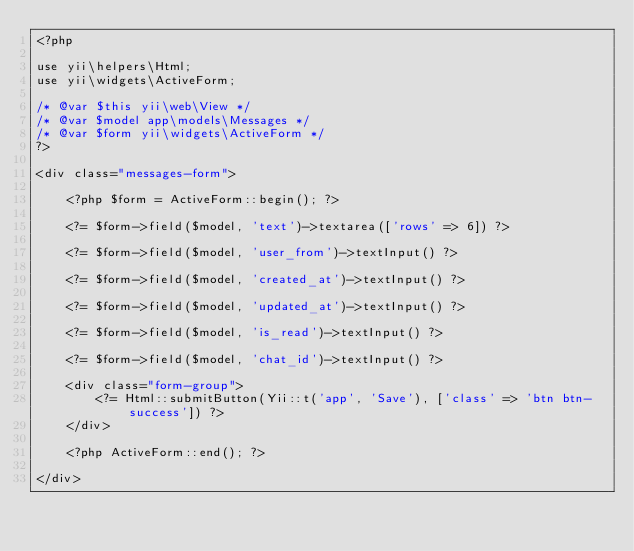<code> <loc_0><loc_0><loc_500><loc_500><_PHP_><?php

use yii\helpers\Html;
use yii\widgets\ActiveForm;

/* @var $this yii\web\View */
/* @var $model app\models\Messages */
/* @var $form yii\widgets\ActiveForm */
?>

<div class="messages-form">

    <?php $form = ActiveForm::begin(); ?>

    <?= $form->field($model, 'text')->textarea(['rows' => 6]) ?>

    <?= $form->field($model, 'user_from')->textInput() ?>

    <?= $form->field($model, 'created_at')->textInput() ?>

    <?= $form->field($model, 'updated_at')->textInput() ?>

    <?= $form->field($model, 'is_read')->textInput() ?>

    <?= $form->field($model, 'chat_id')->textInput() ?>

    <div class="form-group">
        <?= Html::submitButton(Yii::t('app', 'Save'), ['class' => 'btn btn-success']) ?>
    </div>

    <?php ActiveForm::end(); ?>

</div>
</code> 